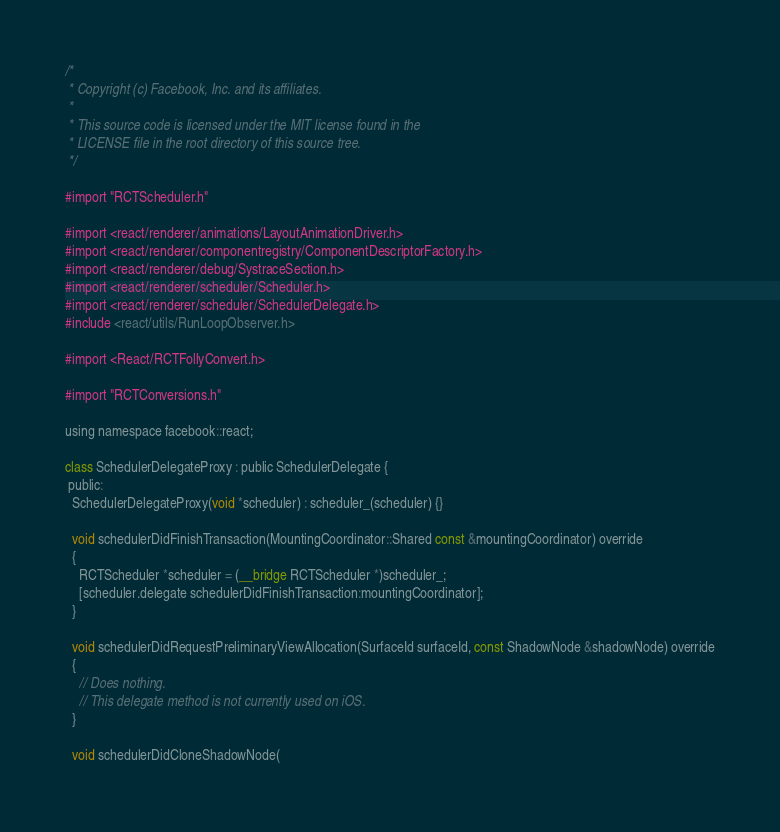Convert code to text. <code><loc_0><loc_0><loc_500><loc_500><_ObjectiveC_>/*
 * Copyright (c) Facebook, Inc. and its affiliates.
 *
 * This source code is licensed under the MIT license found in the
 * LICENSE file in the root directory of this source tree.
 */

#import "RCTScheduler.h"

#import <react/renderer/animations/LayoutAnimationDriver.h>
#import <react/renderer/componentregistry/ComponentDescriptorFactory.h>
#import <react/renderer/debug/SystraceSection.h>
#import <react/renderer/scheduler/Scheduler.h>
#import <react/renderer/scheduler/SchedulerDelegate.h>
#include <react/utils/RunLoopObserver.h>

#import <React/RCTFollyConvert.h>

#import "RCTConversions.h"

using namespace facebook::react;

class SchedulerDelegateProxy : public SchedulerDelegate {
 public:
  SchedulerDelegateProxy(void *scheduler) : scheduler_(scheduler) {}

  void schedulerDidFinishTransaction(MountingCoordinator::Shared const &mountingCoordinator) override
  {
    RCTScheduler *scheduler = (__bridge RCTScheduler *)scheduler_;
    [scheduler.delegate schedulerDidFinishTransaction:mountingCoordinator];
  }

  void schedulerDidRequestPreliminaryViewAllocation(SurfaceId surfaceId, const ShadowNode &shadowNode) override
  {
    // Does nothing.
    // This delegate method is not currently used on iOS.
  }

  void schedulerDidCloneShadowNode(</code> 